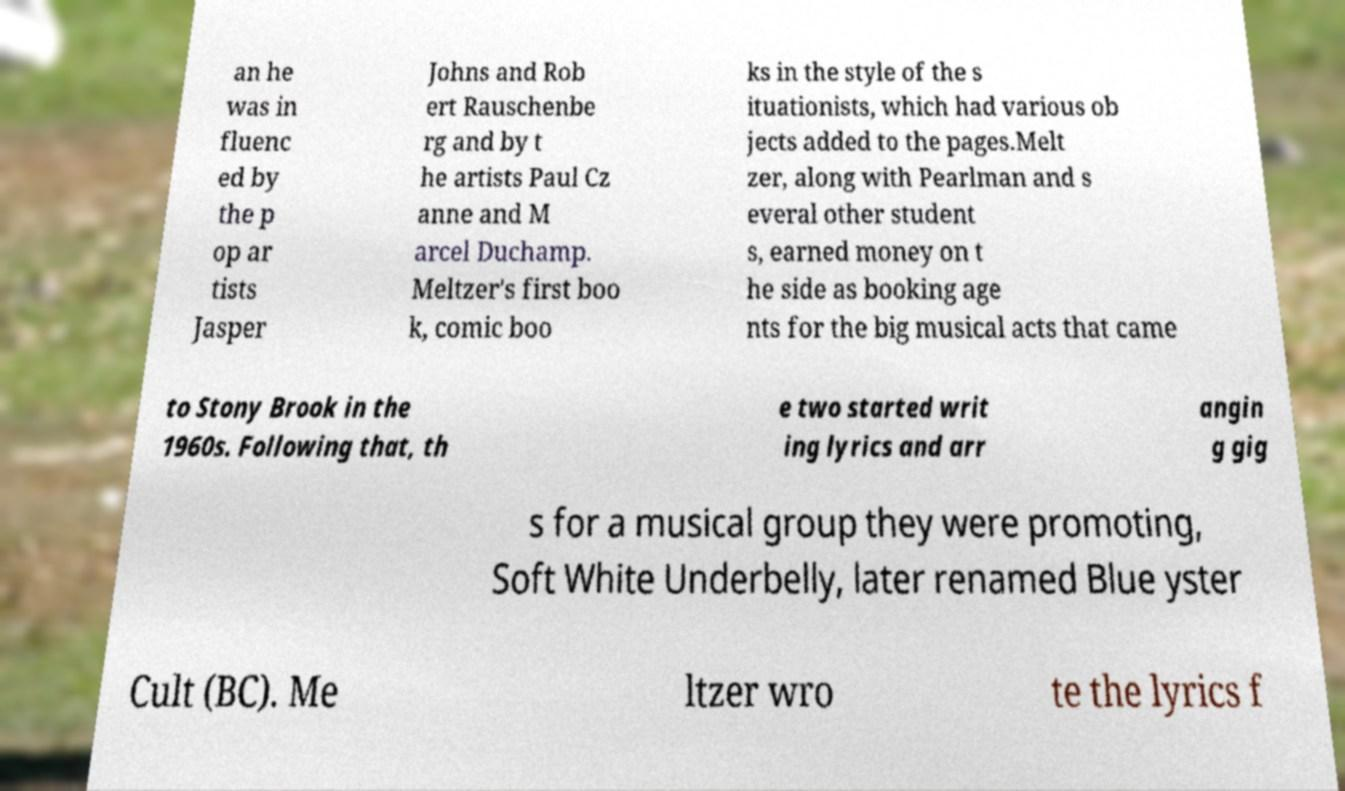Please identify and transcribe the text found in this image. an he was in fluenc ed by the p op ar tists Jasper Johns and Rob ert Rauschenbe rg and by t he artists Paul Cz anne and M arcel Duchamp. Meltzer's first boo k, comic boo ks in the style of the s ituationists, which had various ob jects added to the pages.Melt zer, along with Pearlman and s everal other student s, earned money on t he side as booking age nts for the big musical acts that came to Stony Brook in the 1960s. Following that, th e two started writ ing lyrics and arr angin g gig s for a musical group they were promoting, Soft White Underbelly, later renamed Blue yster Cult (BC). Me ltzer wro te the lyrics f 